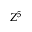<formula> <loc_0><loc_0><loc_500><loc_500>Z ^ { 5 }</formula> 